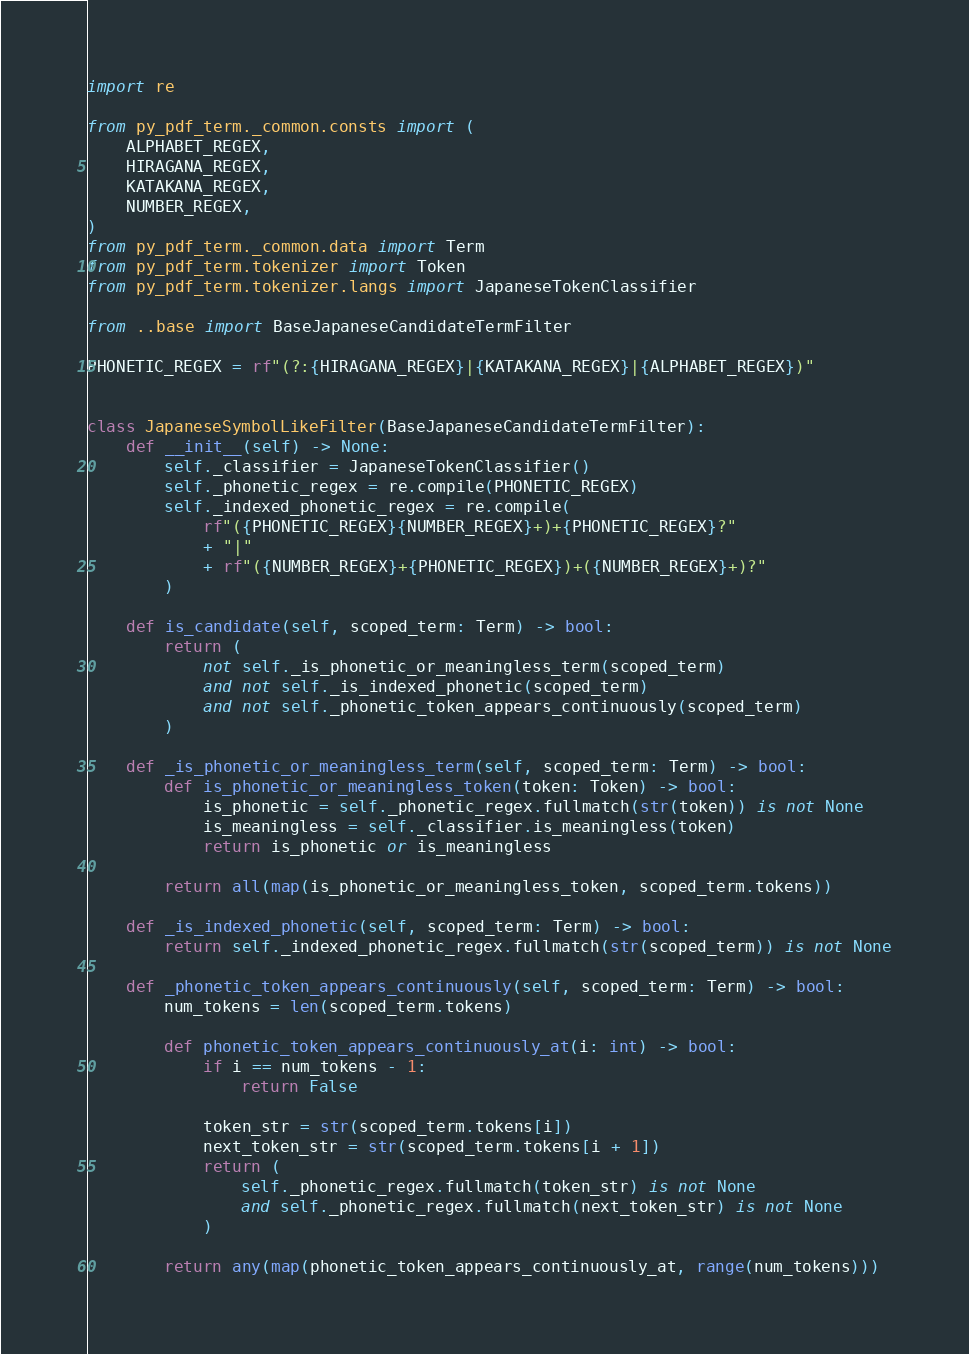<code> <loc_0><loc_0><loc_500><loc_500><_Python_>import re

from py_pdf_term._common.consts import (
    ALPHABET_REGEX,
    HIRAGANA_REGEX,
    KATAKANA_REGEX,
    NUMBER_REGEX,
)
from py_pdf_term._common.data import Term
from py_pdf_term.tokenizer import Token
from py_pdf_term.tokenizer.langs import JapaneseTokenClassifier

from ..base import BaseJapaneseCandidateTermFilter

PHONETIC_REGEX = rf"(?:{HIRAGANA_REGEX}|{KATAKANA_REGEX}|{ALPHABET_REGEX})"


class JapaneseSymbolLikeFilter(BaseJapaneseCandidateTermFilter):
    def __init__(self) -> None:
        self._classifier = JapaneseTokenClassifier()
        self._phonetic_regex = re.compile(PHONETIC_REGEX)
        self._indexed_phonetic_regex = re.compile(
            rf"({PHONETIC_REGEX}{NUMBER_REGEX}+)+{PHONETIC_REGEX}?"
            + "|"
            + rf"({NUMBER_REGEX}+{PHONETIC_REGEX})+({NUMBER_REGEX}+)?"
        )

    def is_candidate(self, scoped_term: Term) -> bool:
        return (
            not self._is_phonetic_or_meaningless_term(scoped_term)
            and not self._is_indexed_phonetic(scoped_term)
            and not self._phonetic_token_appears_continuously(scoped_term)
        )

    def _is_phonetic_or_meaningless_term(self, scoped_term: Term) -> bool:
        def is_phonetic_or_meaningless_token(token: Token) -> bool:
            is_phonetic = self._phonetic_regex.fullmatch(str(token)) is not None
            is_meaningless = self._classifier.is_meaningless(token)
            return is_phonetic or is_meaningless

        return all(map(is_phonetic_or_meaningless_token, scoped_term.tokens))

    def _is_indexed_phonetic(self, scoped_term: Term) -> bool:
        return self._indexed_phonetic_regex.fullmatch(str(scoped_term)) is not None

    def _phonetic_token_appears_continuously(self, scoped_term: Term) -> bool:
        num_tokens = len(scoped_term.tokens)

        def phonetic_token_appears_continuously_at(i: int) -> bool:
            if i == num_tokens - 1:
                return False

            token_str = str(scoped_term.tokens[i])
            next_token_str = str(scoped_term.tokens[i + 1])
            return (
                self._phonetic_regex.fullmatch(token_str) is not None
                and self._phonetic_regex.fullmatch(next_token_str) is not None
            )

        return any(map(phonetic_token_appears_continuously_at, range(num_tokens)))
</code> 